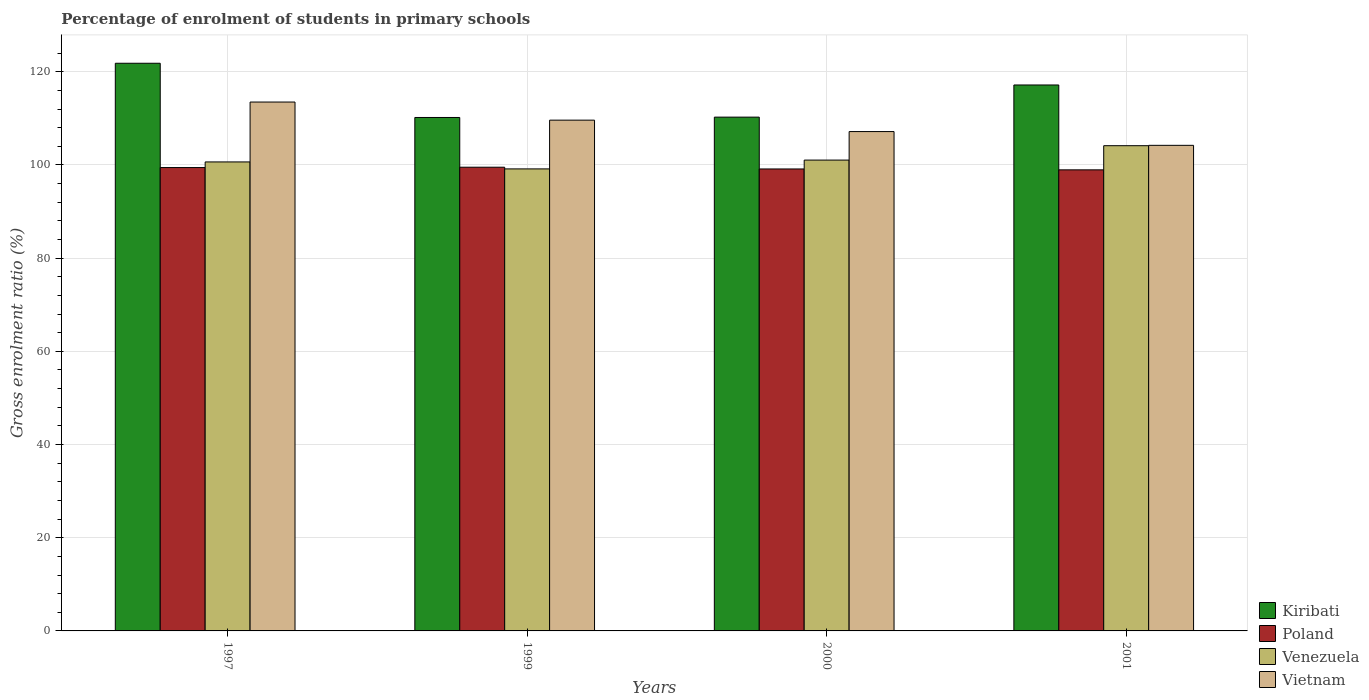How many different coloured bars are there?
Offer a very short reply. 4. How many groups of bars are there?
Your answer should be compact. 4. Are the number of bars per tick equal to the number of legend labels?
Your answer should be very brief. Yes. Are the number of bars on each tick of the X-axis equal?
Your answer should be compact. Yes. In how many cases, is the number of bars for a given year not equal to the number of legend labels?
Offer a terse response. 0. What is the percentage of students enrolled in primary schools in Venezuela in 1997?
Provide a succinct answer. 100.64. Across all years, what is the maximum percentage of students enrolled in primary schools in Venezuela?
Give a very brief answer. 104.13. Across all years, what is the minimum percentage of students enrolled in primary schools in Vietnam?
Keep it short and to the point. 104.2. In which year was the percentage of students enrolled in primary schools in Poland maximum?
Provide a succinct answer. 1999. In which year was the percentage of students enrolled in primary schools in Kiribati minimum?
Offer a terse response. 1999. What is the total percentage of students enrolled in primary schools in Venezuela in the graph?
Offer a terse response. 404.95. What is the difference between the percentage of students enrolled in primary schools in Venezuela in 1997 and that in 2000?
Provide a succinct answer. -0.39. What is the difference between the percentage of students enrolled in primary schools in Vietnam in 2000 and the percentage of students enrolled in primary schools in Venezuela in 1997?
Provide a short and direct response. 6.52. What is the average percentage of students enrolled in primary schools in Vietnam per year?
Make the answer very short. 108.62. In the year 1999, what is the difference between the percentage of students enrolled in primary schools in Venezuela and percentage of students enrolled in primary schools in Poland?
Your response must be concise. -0.36. In how many years, is the percentage of students enrolled in primary schools in Poland greater than 68 %?
Offer a very short reply. 4. What is the ratio of the percentage of students enrolled in primary schools in Vietnam in 1997 to that in 2000?
Offer a terse response. 1.06. Is the percentage of students enrolled in primary schools in Vietnam in 1999 less than that in 2000?
Provide a short and direct response. No. Is the difference between the percentage of students enrolled in primary schools in Venezuela in 1999 and 2000 greater than the difference between the percentage of students enrolled in primary schools in Poland in 1999 and 2000?
Provide a succinct answer. No. What is the difference between the highest and the second highest percentage of students enrolled in primary schools in Vietnam?
Provide a short and direct response. 3.89. What is the difference between the highest and the lowest percentage of students enrolled in primary schools in Venezuela?
Offer a very short reply. 4.98. Is it the case that in every year, the sum of the percentage of students enrolled in primary schools in Poland and percentage of students enrolled in primary schools in Venezuela is greater than the sum of percentage of students enrolled in primary schools in Vietnam and percentage of students enrolled in primary schools in Kiribati?
Ensure brevity in your answer.  Yes. What does the 4th bar from the left in 1997 represents?
Offer a terse response. Vietnam. What does the 2nd bar from the right in 1997 represents?
Offer a very short reply. Venezuela. What is the difference between two consecutive major ticks on the Y-axis?
Offer a terse response. 20. Are the values on the major ticks of Y-axis written in scientific E-notation?
Your answer should be very brief. No. Does the graph contain any zero values?
Your answer should be compact. No. Does the graph contain grids?
Your answer should be compact. Yes. Where does the legend appear in the graph?
Offer a very short reply. Bottom right. How are the legend labels stacked?
Your response must be concise. Vertical. What is the title of the graph?
Provide a succinct answer. Percentage of enrolment of students in primary schools. What is the label or title of the X-axis?
Make the answer very short. Years. What is the Gross enrolment ratio (%) of Kiribati in 1997?
Ensure brevity in your answer.  121.82. What is the Gross enrolment ratio (%) of Poland in 1997?
Keep it short and to the point. 99.44. What is the Gross enrolment ratio (%) of Venezuela in 1997?
Give a very brief answer. 100.64. What is the Gross enrolment ratio (%) in Vietnam in 1997?
Provide a succinct answer. 113.5. What is the Gross enrolment ratio (%) of Kiribati in 1999?
Your response must be concise. 110.18. What is the Gross enrolment ratio (%) in Poland in 1999?
Your answer should be very brief. 99.51. What is the Gross enrolment ratio (%) of Venezuela in 1999?
Your response must be concise. 99.15. What is the Gross enrolment ratio (%) of Vietnam in 1999?
Make the answer very short. 109.61. What is the Gross enrolment ratio (%) in Kiribati in 2000?
Your response must be concise. 110.26. What is the Gross enrolment ratio (%) in Poland in 2000?
Provide a short and direct response. 99.13. What is the Gross enrolment ratio (%) of Venezuela in 2000?
Give a very brief answer. 101.04. What is the Gross enrolment ratio (%) of Vietnam in 2000?
Give a very brief answer. 107.16. What is the Gross enrolment ratio (%) of Kiribati in 2001?
Your answer should be compact. 117.16. What is the Gross enrolment ratio (%) in Poland in 2001?
Offer a very short reply. 98.94. What is the Gross enrolment ratio (%) of Venezuela in 2001?
Your answer should be compact. 104.13. What is the Gross enrolment ratio (%) of Vietnam in 2001?
Ensure brevity in your answer.  104.2. Across all years, what is the maximum Gross enrolment ratio (%) of Kiribati?
Make the answer very short. 121.82. Across all years, what is the maximum Gross enrolment ratio (%) of Poland?
Your answer should be compact. 99.51. Across all years, what is the maximum Gross enrolment ratio (%) in Venezuela?
Provide a succinct answer. 104.13. Across all years, what is the maximum Gross enrolment ratio (%) of Vietnam?
Make the answer very short. 113.5. Across all years, what is the minimum Gross enrolment ratio (%) in Kiribati?
Give a very brief answer. 110.18. Across all years, what is the minimum Gross enrolment ratio (%) in Poland?
Ensure brevity in your answer.  98.94. Across all years, what is the minimum Gross enrolment ratio (%) in Venezuela?
Provide a succinct answer. 99.15. Across all years, what is the minimum Gross enrolment ratio (%) in Vietnam?
Your answer should be very brief. 104.2. What is the total Gross enrolment ratio (%) of Kiribati in the graph?
Provide a short and direct response. 459.41. What is the total Gross enrolment ratio (%) of Poland in the graph?
Give a very brief answer. 397.02. What is the total Gross enrolment ratio (%) in Venezuela in the graph?
Provide a short and direct response. 404.95. What is the total Gross enrolment ratio (%) of Vietnam in the graph?
Offer a very short reply. 434.47. What is the difference between the Gross enrolment ratio (%) in Kiribati in 1997 and that in 1999?
Give a very brief answer. 11.64. What is the difference between the Gross enrolment ratio (%) in Poland in 1997 and that in 1999?
Give a very brief answer. -0.08. What is the difference between the Gross enrolment ratio (%) of Venezuela in 1997 and that in 1999?
Offer a very short reply. 1.5. What is the difference between the Gross enrolment ratio (%) in Vietnam in 1997 and that in 1999?
Provide a succinct answer. 3.89. What is the difference between the Gross enrolment ratio (%) of Kiribati in 1997 and that in 2000?
Your answer should be very brief. 11.56. What is the difference between the Gross enrolment ratio (%) in Poland in 1997 and that in 2000?
Give a very brief answer. 0.3. What is the difference between the Gross enrolment ratio (%) of Venezuela in 1997 and that in 2000?
Ensure brevity in your answer.  -0.4. What is the difference between the Gross enrolment ratio (%) in Vietnam in 1997 and that in 2000?
Your answer should be compact. 6.34. What is the difference between the Gross enrolment ratio (%) in Kiribati in 1997 and that in 2001?
Ensure brevity in your answer.  4.66. What is the difference between the Gross enrolment ratio (%) of Poland in 1997 and that in 2001?
Your answer should be compact. 0.49. What is the difference between the Gross enrolment ratio (%) in Venezuela in 1997 and that in 2001?
Offer a very short reply. -3.48. What is the difference between the Gross enrolment ratio (%) of Vietnam in 1997 and that in 2001?
Provide a short and direct response. 9.29. What is the difference between the Gross enrolment ratio (%) in Kiribati in 1999 and that in 2000?
Offer a very short reply. -0.08. What is the difference between the Gross enrolment ratio (%) of Poland in 1999 and that in 2000?
Provide a succinct answer. 0.38. What is the difference between the Gross enrolment ratio (%) of Venezuela in 1999 and that in 2000?
Provide a succinct answer. -1.89. What is the difference between the Gross enrolment ratio (%) in Vietnam in 1999 and that in 2000?
Give a very brief answer. 2.45. What is the difference between the Gross enrolment ratio (%) in Kiribati in 1999 and that in 2001?
Your answer should be compact. -6.97. What is the difference between the Gross enrolment ratio (%) of Poland in 1999 and that in 2001?
Your answer should be compact. 0.57. What is the difference between the Gross enrolment ratio (%) of Venezuela in 1999 and that in 2001?
Give a very brief answer. -4.98. What is the difference between the Gross enrolment ratio (%) of Vietnam in 1999 and that in 2001?
Provide a succinct answer. 5.41. What is the difference between the Gross enrolment ratio (%) of Kiribati in 2000 and that in 2001?
Make the answer very short. -6.9. What is the difference between the Gross enrolment ratio (%) of Poland in 2000 and that in 2001?
Offer a terse response. 0.19. What is the difference between the Gross enrolment ratio (%) of Venezuela in 2000 and that in 2001?
Offer a terse response. -3.09. What is the difference between the Gross enrolment ratio (%) of Vietnam in 2000 and that in 2001?
Your answer should be compact. 2.96. What is the difference between the Gross enrolment ratio (%) in Kiribati in 1997 and the Gross enrolment ratio (%) in Poland in 1999?
Your response must be concise. 22.31. What is the difference between the Gross enrolment ratio (%) in Kiribati in 1997 and the Gross enrolment ratio (%) in Venezuela in 1999?
Ensure brevity in your answer.  22.67. What is the difference between the Gross enrolment ratio (%) in Kiribati in 1997 and the Gross enrolment ratio (%) in Vietnam in 1999?
Make the answer very short. 12.21. What is the difference between the Gross enrolment ratio (%) of Poland in 1997 and the Gross enrolment ratio (%) of Venezuela in 1999?
Offer a very short reply. 0.29. What is the difference between the Gross enrolment ratio (%) of Poland in 1997 and the Gross enrolment ratio (%) of Vietnam in 1999?
Ensure brevity in your answer.  -10.17. What is the difference between the Gross enrolment ratio (%) in Venezuela in 1997 and the Gross enrolment ratio (%) in Vietnam in 1999?
Provide a succinct answer. -8.97. What is the difference between the Gross enrolment ratio (%) in Kiribati in 1997 and the Gross enrolment ratio (%) in Poland in 2000?
Give a very brief answer. 22.68. What is the difference between the Gross enrolment ratio (%) in Kiribati in 1997 and the Gross enrolment ratio (%) in Venezuela in 2000?
Offer a very short reply. 20.78. What is the difference between the Gross enrolment ratio (%) of Kiribati in 1997 and the Gross enrolment ratio (%) of Vietnam in 2000?
Your answer should be compact. 14.66. What is the difference between the Gross enrolment ratio (%) of Poland in 1997 and the Gross enrolment ratio (%) of Venezuela in 2000?
Keep it short and to the point. -1.6. What is the difference between the Gross enrolment ratio (%) in Poland in 1997 and the Gross enrolment ratio (%) in Vietnam in 2000?
Keep it short and to the point. -7.72. What is the difference between the Gross enrolment ratio (%) of Venezuela in 1997 and the Gross enrolment ratio (%) of Vietnam in 2000?
Make the answer very short. -6.52. What is the difference between the Gross enrolment ratio (%) of Kiribati in 1997 and the Gross enrolment ratio (%) of Poland in 2001?
Your answer should be very brief. 22.87. What is the difference between the Gross enrolment ratio (%) of Kiribati in 1997 and the Gross enrolment ratio (%) of Venezuela in 2001?
Ensure brevity in your answer.  17.69. What is the difference between the Gross enrolment ratio (%) in Kiribati in 1997 and the Gross enrolment ratio (%) in Vietnam in 2001?
Provide a succinct answer. 17.61. What is the difference between the Gross enrolment ratio (%) of Poland in 1997 and the Gross enrolment ratio (%) of Venezuela in 2001?
Provide a short and direct response. -4.69. What is the difference between the Gross enrolment ratio (%) of Poland in 1997 and the Gross enrolment ratio (%) of Vietnam in 2001?
Keep it short and to the point. -4.77. What is the difference between the Gross enrolment ratio (%) of Venezuela in 1997 and the Gross enrolment ratio (%) of Vietnam in 2001?
Give a very brief answer. -3.56. What is the difference between the Gross enrolment ratio (%) in Kiribati in 1999 and the Gross enrolment ratio (%) in Poland in 2000?
Give a very brief answer. 11.05. What is the difference between the Gross enrolment ratio (%) in Kiribati in 1999 and the Gross enrolment ratio (%) in Venezuela in 2000?
Provide a succinct answer. 9.14. What is the difference between the Gross enrolment ratio (%) in Kiribati in 1999 and the Gross enrolment ratio (%) in Vietnam in 2000?
Your answer should be very brief. 3.02. What is the difference between the Gross enrolment ratio (%) in Poland in 1999 and the Gross enrolment ratio (%) in Venezuela in 2000?
Give a very brief answer. -1.53. What is the difference between the Gross enrolment ratio (%) of Poland in 1999 and the Gross enrolment ratio (%) of Vietnam in 2000?
Offer a terse response. -7.65. What is the difference between the Gross enrolment ratio (%) in Venezuela in 1999 and the Gross enrolment ratio (%) in Vietnam in 2000?
Offer a terse response. -8.01. What is the difference between the Gross enrolment ratio (%) in Kiribati in 1999 and the Gross enrolment ratio (%) in Poland in 2001?
Make the answer very short. 11.24. What is the difference between the Gross enrolment ratio (%) of Kiribati in 1999 and the Gross enrolment ratio (%) of Venezuela in 2001?
Your answer should be compact. 6.05. What is the difference between the Gross enrolment ratio (%) in Kiribati in 1999 and the Gross enrolment ratio (%) in Vietnam in 2001?
Ensure brevity in your answer.  5.98. What is the difference between the Gross enrolment ratio (%) of Poland in 1999 and the Gross enrolment ratio (%) of Venezuela in 2001?
Offer a very short reply. -4.62. What is the difference between the Gross enrolment ratio (%) in Poland in 1999 and the Gross enrolment ratio (%) in Vietnam in 2001?
Provide a succinct answer. -4.69. What is the difference between the Gross enrolment ratio (%) of Venezuela in 1999 and the Gross enrolment ratio (%) of Vietnam in 2001?
Your answer should be very brief. -5.06. What is the difference between the Gross enrolment ratio (%) in Kiribati in 2000 and the Gross enrolment ratio (%) in Poland in 2001?
Give a very brief answer. 11.31. What is the difference between the Gross enrolment ratio (%) of Kiribati in 2000 and the Gross enrolment ratio (%) of Venezuela in 2001?
Your response must be concise. 6.13. What is the difference between the Gross enrolment ratio (%) of Kiribati in 2000 and the Gross enrolment ratio (%) of Vietnam in 2001?
Ensure brevity in your answer.  6.05. What is the difference between the Gross enrolment ratio (%) in Poland in 2000 and the Gross enrolment ratio (%) in Venezuela in 2001?
Offer a very short reply. -4.99. What is the difference between the Gross enrolment ratio (%) in Poland in 2000 and the Gross enrolment ratio (%) in Vietnam in 2001?
Keep it short and to the point. -5.07. What is the difference between the Gross enrolment ratio (%) of Venezuela in 2000 and the Gross enrolment ratio (%) of Vietnam in 2001?
Offer a terse response. -3.17. What is the average Gross enrolment ratio (%) of Kiribati per year?
Offer a terse response. 114.85. What is the average Gross enrolment ratio (%) in Poland per year?
Ensure brevity in your answer.  99.26. What is the average Gross enrolment ratio (%) in Venezuela per year?
Your answer should be compact. 101.24. What is the average Gross enrolment ratio (%) of Vietnam per year?
Your response must be concise. 108.62. In the year 1997, what is the difference between the Gross enrolment ratio (%) of Kiribati and Gross enrolment ratio (%) of Poland?
Offer a terse response. 22.38. In the year 1997, what is the difference between the Gross enrolment ratio (%) of Kiribati and Gross enrolment ratio (%) of Venezuela?
Offer a very short reply. 21.18. In the year 1997, what is the difference between the Gross enrolment ratio (%) in Kiribati and Gross enrolment ratio (%) in Vietnam?
Your response must be concise. 8.32. In the year 1997, what is the difference between the Gross enrolment ratio (%) in Poland and Gross enrolment ratio (%) in Venezuela?
Offer a terse response. -1.21. In the year 1997, what is the difference between the Gross enrolment ratio (%) in Poland and Gross enrolment ratio (%) in Vietnam?
Give a very brief answer. -14.06. In the year 1997, what is the difference between the Gross enrolment ratio (%) in Venezuela and Gross enrolment ratio (%) in Vietnam?
Provide a short and direct response. -12.85. In the year 1999, what is the difference between the Gross enrolment ratio (%) of Kiribati and Gross enrolment ratio (%) of Poland?
Your answer should be compact. 10.67. In the year 1999, what is the difference between the Gross enrolment ratio (%) of Kiribati and Gross enrolment ratio (%) of Venezuela?
Make the answer very short. 11.04. In the year 1999, what is the difference between the Gross enrolment ratio (%) of Kiribati and Gross enrolment ratio (%) of Vietnam?
Your answer should be compact. 0.57. In the year 1999, what is the difference between the Gross enrolment ratio (%) in Poland and Gross enrolment ratio (%) in Venezuela?
Provide a succinct answer. 0.36. In the year 1999, what is the difference between the Gross enrolment ratio (%) of Poland and Gross enrolment ratio (%) of Vietnam?
Keep it short and to the point. -10.1. In the year 1999, what is the difference between the Gross enrolment ratio (%) in Venezuela and Gross enrolment ratio (%) in Vietnam?
Offer a terse response. -10.46. In the year 2000, what is the difference between the Gross enrolment ratio (%) in Kiribati and Gross enrolment ratio (%) in Poland?
Ensure brevity in your answer.  11.12. In the year 2000, what is the difference between the Gross enrolment ratio (%) in Kiribati and Gross enrolment ratio (%) in Venezuela?
Provide a short and direct response. 9.22. In the year 2000, what is the difference between the Gross enrolment ratio (%) of Kiribati and Gross enrolment ratio (%) of Vietnam?
Keep it short and to the point. 3.1. In the year 2000, what is the difference between the Gross enrolment ratio (%) in Poland and Gross enrolment ratio (%) in Venezuela?
Your answer should be compact. -1.9. In the year 2000, what is the difference between the Gross enrolment ratio (%) of Poland and Gross enrolment ratio (%) of Vietnam?
Keep it short and to the point. -8.03. In the year 2000, what is the difference between the Gross enrolment ratio (%) of Venezuela and Gross enrolment ratio (%) of Vietnam?
Your response must be concise. -6.12. In the year 2001, what is the difference between the Gross enrolment ratio (%) of Kiribati and Gross enrolment ratio (%) of Poland?
Ensure brevity in your answer.  18.21. In the year 2001, what is the difference between the Gross enrolment ratio (%) of Kiribati and Gross enrolment ratio (%) of Venezuela?
Your answer should be compact. 13.03. In the year 2001, what is the difference between the Gross enrolment ratio (%) of Kiribati and Gross enrolment ratio (%) of Vietnam?
Keep it short and to the point. 12.95. In the year 2001, what is the difference between the Gross enrolment ratio (%) in Poland and Gross enrolment ratio (%) in Venezuela?
Offer a very short reply. -5.18. In the year 2001, what is the difference between the Gross enrolment ratio (%) in Poland and Gross enrolment ratio (%) in Vietnam?
Your answer should be very brief. -5.26. In the year 2001, what is the difference between the Gross enrolment ratio (%) of Venezuela and Gross enrolment ratio (%) of Vietnam?
Offer a very short reply. -0.08. What is the ratio of the Gross enrolment ratio (%) of Kiribati in 1997 to that in 1999?
Provide a succinct answer. 1.11. What is the ratio of the Gross enrolment ratio (%) of Venezuela in 1997 to that in 1999?
Ensure brevity in your answer.  1.02. What is the ratio of the Gross enrolment ratio (%) in Vietnam in 1997 to that in 1999?
Provide a succinct answer. 1.04. What is the ratio of the Gross enrolment ratio (%) of Kiribati in 1997 to that in 2000?
Your response must be concise. 1.1. What is the ratio of the Gross enrolment ratio (%) in Venezuela in 1997 to that in 2000?
Provide a short and direct response. 1. What is the ratio of the Gross enrolment ratio (%) in Vietnam in 1997 to that in 2000?
Your answer should be very brief. 1.06. What is the ratio of the Gross enrolment ratio (%) in Kiribati in 1997 to that in 2001?
Provide a short and direct response. 1.04. What is the ratio of the Gross enrolment ratio (%) in Venezuela in 1997 to that in 2001?
Offer a terse response. 0.97. What is the ratio of the Gross enrolment ratio (%) in Vietnam in 1997 to that in 2001?
Your answer should be compact. 1.09. What is the ratio of the Gross enrolment ratio (%) of Kiribati in 1999 to that in 2000?
Offer a terse response. 1. What is the ratio of the Gross enrolment ratio (%) of Poland in 1999 to that in 2000?
Ensure brevity in your answer.  1. What is the ratio of the Gross enrolment ratio (%) in Venezuela in 1999 to that in 2000?
Keep it short and to the point. 0.98. What is the ratio of the Gross enrolment ratio (%) of Vietnam in 1999 to that in 2000?
Make the answer very short. 1.02. What is the ratio of the Gross enrolment ratio (%) in Kiribati in 1999 to that in 2001?
Provide a short and direct response. 0.94. What is the ratio of the Gross enrolment ratio (%) of Poland in 1999 to that in 2001?
Provide a short and direct response. 1.01. What is the ratio of the Gross enrolment ratio (%) in Venezuela in 1999 to that in 2001?
Offer a very short reply. 0.95. What is the ratio of the Gross enrolment ratio (%) of Vietnam in 1999 to that in 2001?
Offer a very short reply. 1.05. What is the ratio of the Gross enrolment ratio (%) of Kiribati in 2000 to that in 2001?
Keep it short and to the point. 0.94. What is the ratio of the Gross enrolment ratio (%) in Venezuela in 2000 to that in 2001?
Offer a terse response. 0.97. What is the ratio of the Gross enrolment ratio (%) of Vietnam in 2000 to that in 2001?
Ensure brevity in your answer.  1.03. What is the difference between the highest and the second highest Gross enrolment ratio (%) in Kiribati?
Ensure brevity in your answer.  4.66. What is the difference between the highest and the second highest Gross enrolment ratio (%) in Poland?
Provide a succinct answer. 0.08. What is the difference between the highest and the second highest Gross enrolment ratio (%) in Venezuela?
Offer a very short reply. 3.09. What is the difference between the highest and the second highest Gross enrolment ratio (%) in Vietnam?
Provide a succinct answer. 3.89. What is the difference between the highest and the lowest Gross enrolment ratio (%) of Kiribati?
Offer a very short reply. 11.64. What is the difference between the highest and the lowest Gross enrolment ratio (%) in Poland?
Provide a short and direct response. 0.57. What is the difference between the highest and the lowest Gross enrolment ratio (%) of Venezuela?
Offer a terse response. 4.98. What is the difference between the highest and the lowest Gross enrolment ratio (%) in Vietnam?
Make the answer very short. 9.29. 